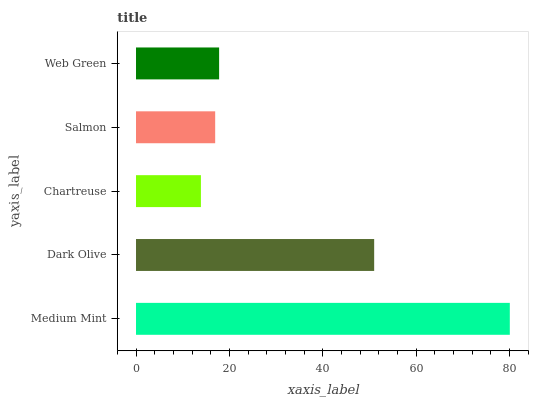Is Chartreuse the minimum?
Answer yes or no. Yes. Is Medium Mint the maximum?
Answer yes or no. Yes. Is Dark Olive the minimum?
Answer yes or no. No. Is Dark Olive the maximum?
Answer yes or no. No. Is Medium Mint greater than Dark Olive?
Answer yes or no. Yes. Is Dark Olive less than Medium Mint?
Answer yes or no. Yes. Is Dark Olive greater than Medium Mint?
Answer yes or no. No. Is Medium Mint less than Dark Olive?
Answer yes or no. No. Is Web Green the high median?
Answer yes or no. Yes. Is Web Green the low median?
Answer yes or no. Yes. Is Salmon the high median?
Answer yes or no. No. Is Salmon the low median?
Answer yes or no. No. 